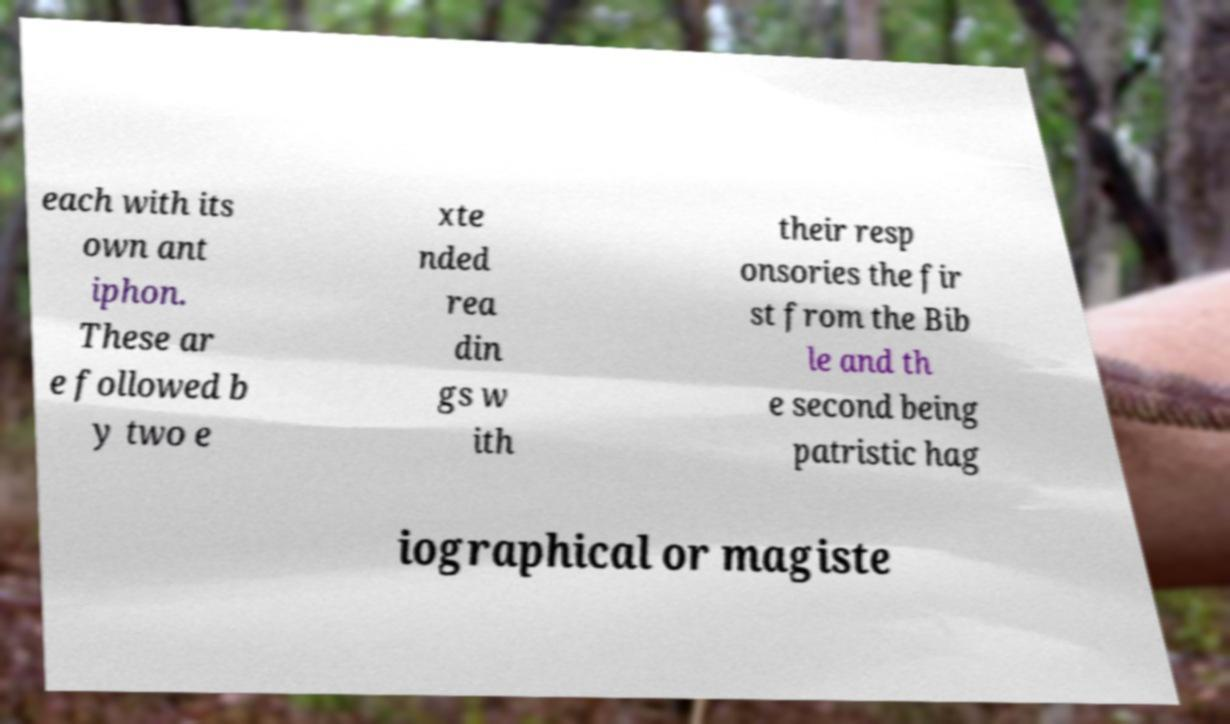Please read and relay the text visible in this image. What does it say? each with its own ant iphon. These ar e followed b y two e xte nded rea din gs w ith their resp onsories the fir st from the Bib le and th e second being patristic hag iographical or magiste 